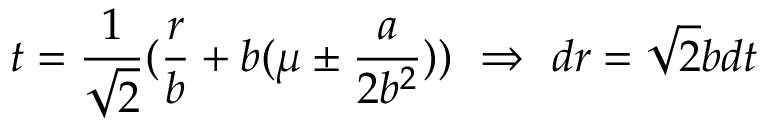<formula> <loc_0><loc_0><loc_500><loc_500>t = \frac { 1 } { \sqrt { 2 } } ( \frac { r } { b } + b ( \mu \pm \frac { a } { 2 b ^ { 2 } } ) ) \ \Rightarrow \ d r = \sqrt { 2 } b d t</formula> 